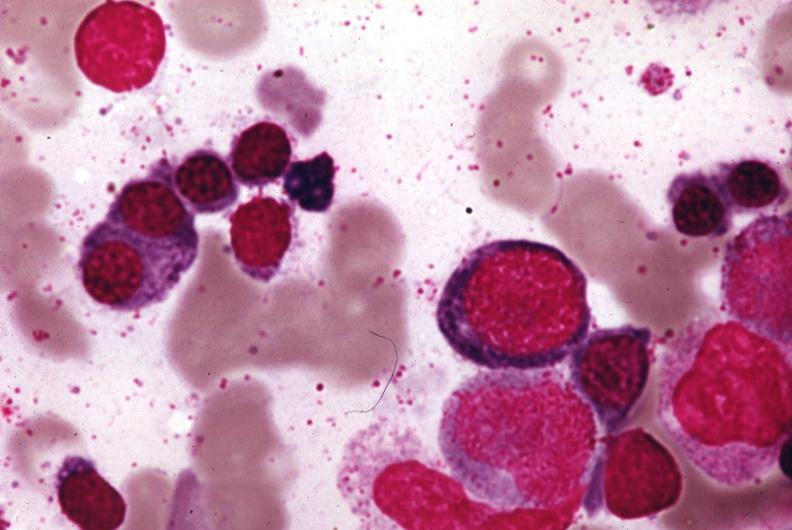does this image show wrights stain?
Answer the question using a single word or phrase. Yes 